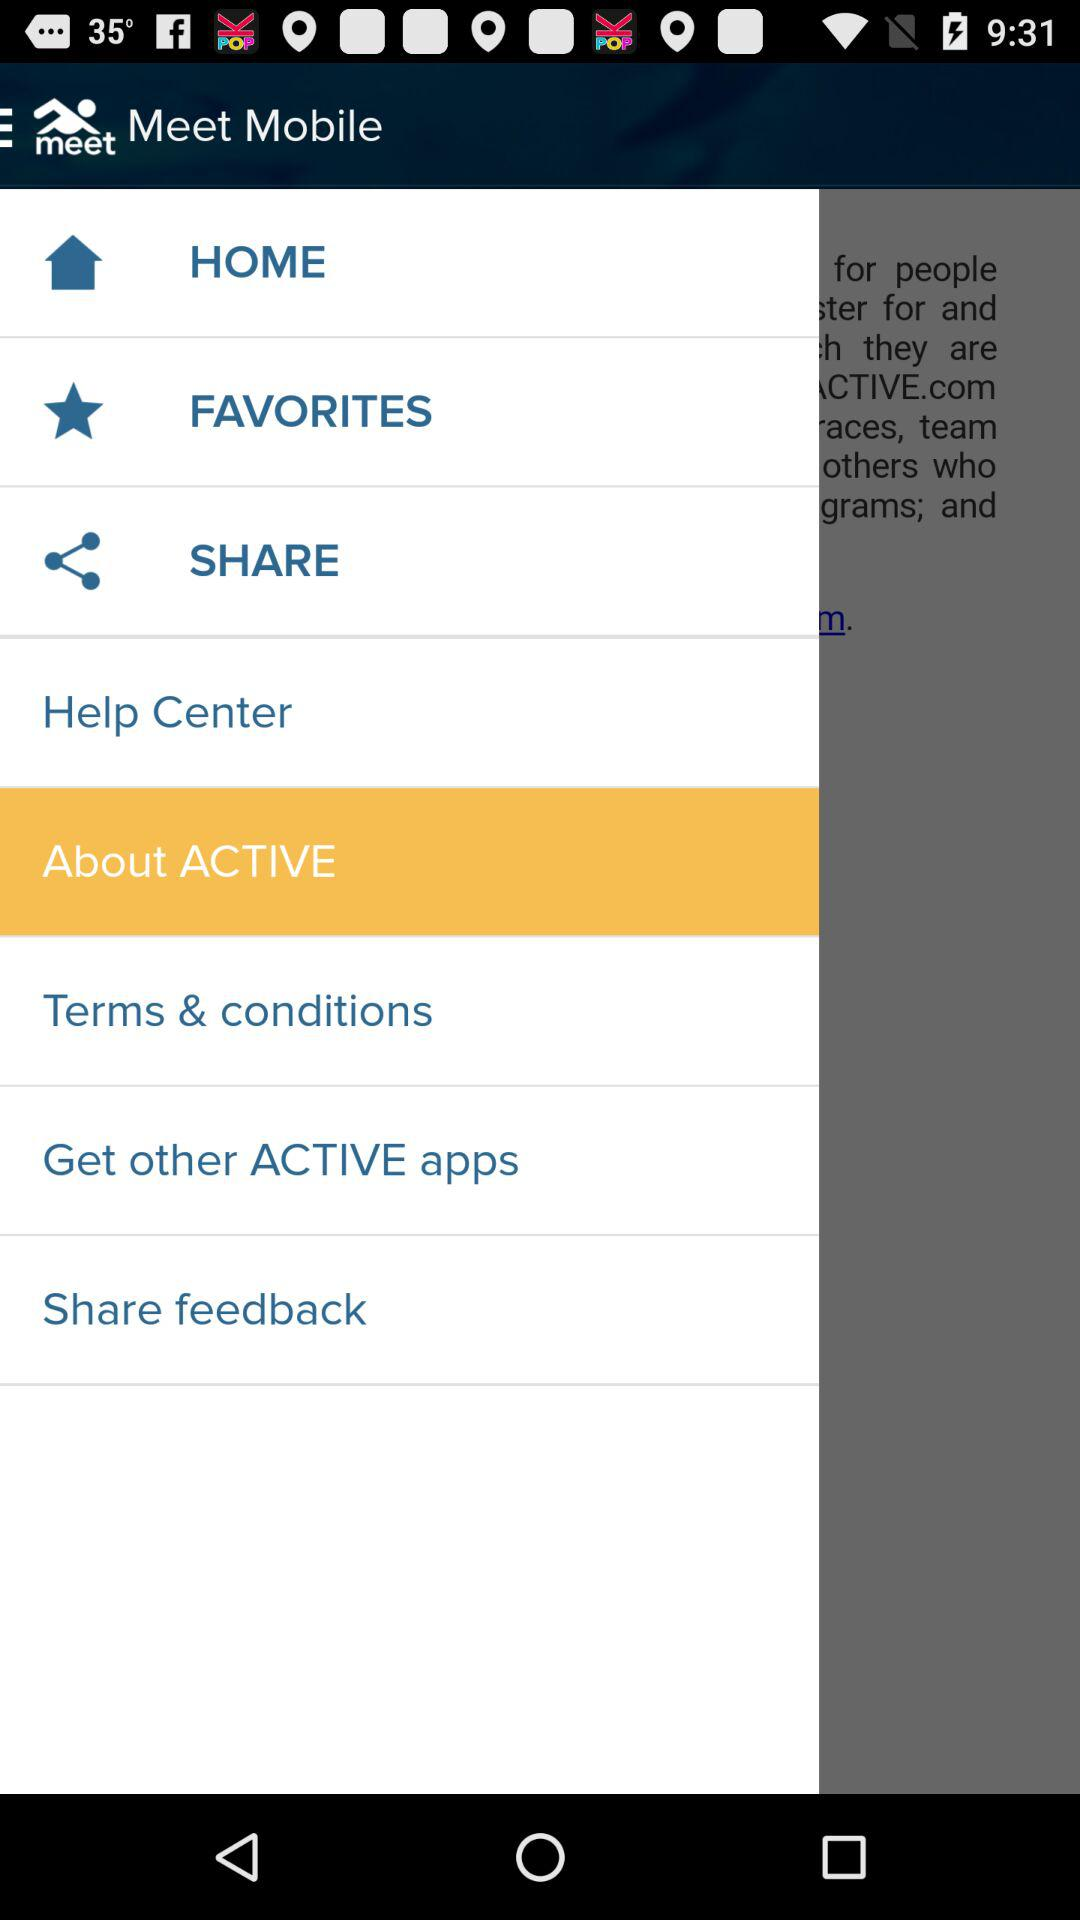What is the name of the application? The name of the application is "Meet Mobile". 